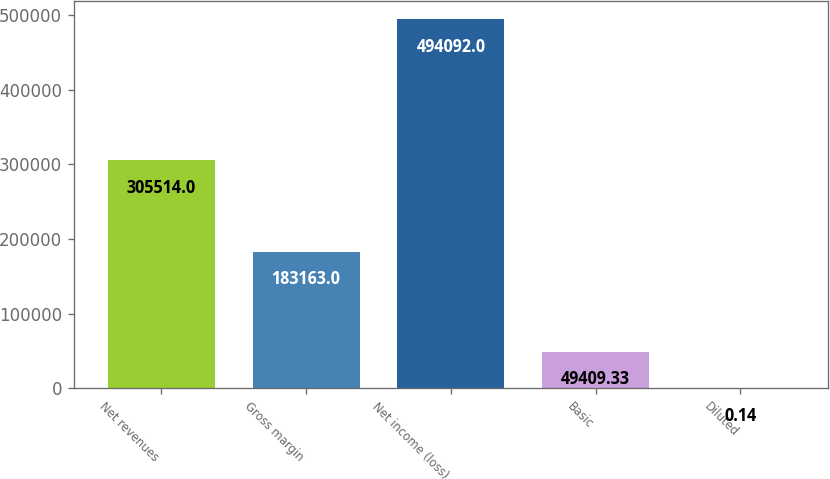Convert chart to OTSL. <chart><loc_0><loc_0><loc_500><loc_500><bar_chart><fcel>Net revenues<fcel>Gross margin<fcel>Net income (loss)<fcel>Basic<fcel>Diluted<nl><fcel>305514<fcel>183163<fcel>494092<fcel>49409.3<fcel>0.14<nl></chart> 